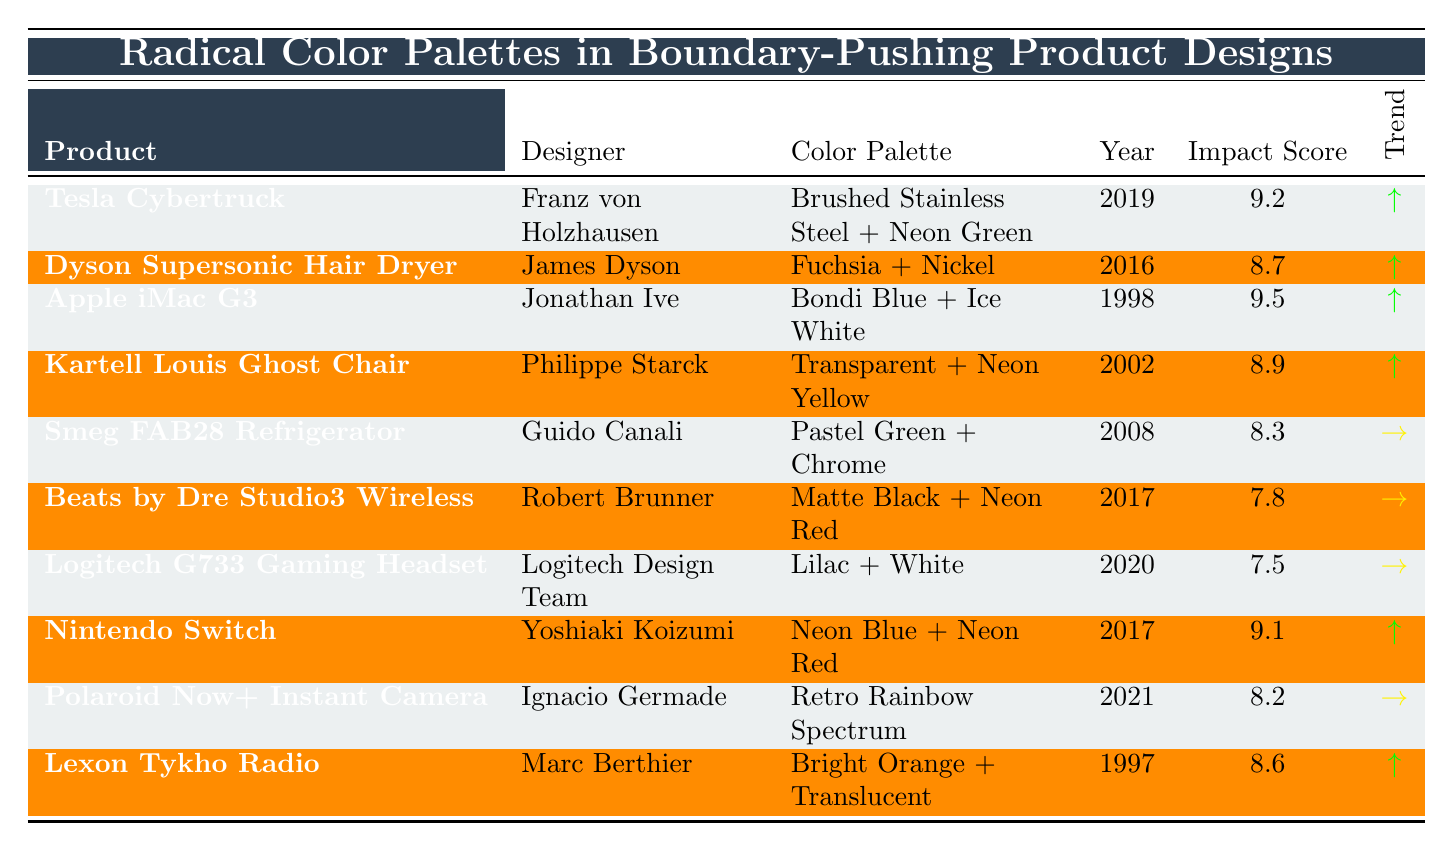What is the highest Impact Score among the products listed? The table shows the Impact Scores for each product. The highest score is 9.5, attributed to the Apple iMac G3.
Answer: 9.5 Which designer created the Tesla Cybertruck? The table lists Franz von Holzhausen as the designer of the Tesla Cybertruck.
Answer: Franz von Holzhausen How many products have an Impact Score greater than 8.5? The table shows the Impact Scores for each product. The products with scores greater than 8.5 are the Tesla Cybertruck, Apple iMac G3, Dyson Supersonic Hair Dryer, Nintendo Switch, and Kartell Louis Ghost Chair. There are a total of 5 such products.
Answer: 5 What is the color palette used for the Smeg FAB28 Refrigerator? According to the table, the color palette of the Smeg FAB28 Refrigerator is Pastel Green + Chrome.
Answer: Pastel Green + Chrome Did any products have a color palette with the word "Neon" in it? By checking through the table, it can be seen that the Tesla Cybertruck and Nintendo Switch include "Neon" in their color palettes.
Answer: Yes Which product was designed in 2021 and what is its Impact Score? The only product designed in 2021 is the Polaroid Now+ Instant Camera, which has an Impact Score of 8.2.
Answer: Polaroid Now+ Instant Camera, 8.2 What is the average Impact Score for products designed after 2015? The relevant products are the Tesla Cybertruck, Dyson Supersonic Hair Dryer, Beats by Dre Studio3 Wireless, Logitech G733 Gaming Headset, Nintendo Switch, and Polaroid Now+ Instant Camera. Their scores are: 9.2, 8.7, 7.8, 7.5, 9.1, and 8.2. The average is (9.2 + 8.7 + 7.8 + 7.5 + 9.1 + 8.2) / 6 = 8.6.
Answer: 8.6 What color palettes are associated with products that have an Impact Score less than 8? In the table, the only product with an Impact Score less than 8 is the Beats by Dre Studio3 Wireless, which has a color palette of Matte Black + Neon Red.
Answer: Matte Black + Neon Red Which product has the most recent design year, and what is its Impact Score? The most recent product design year listed is 2021, which corresponds to the Polaroid Now+ Instant Camera, featuring an Impact Score of 8.2.
Answer: Polaroid Now+ Instant Camera, 8.2 Are there any products from the year 2000 or later that feature the color Neon? The products designed in 2000 or later that include "Neon" in their color palette are the Tesla Cybertruck (2019), Beats by Dre Studio3 Wireless (2017), and Nintendo Switch (2017). Therefore, there are products meeting the criteria.
Answer: Yes 